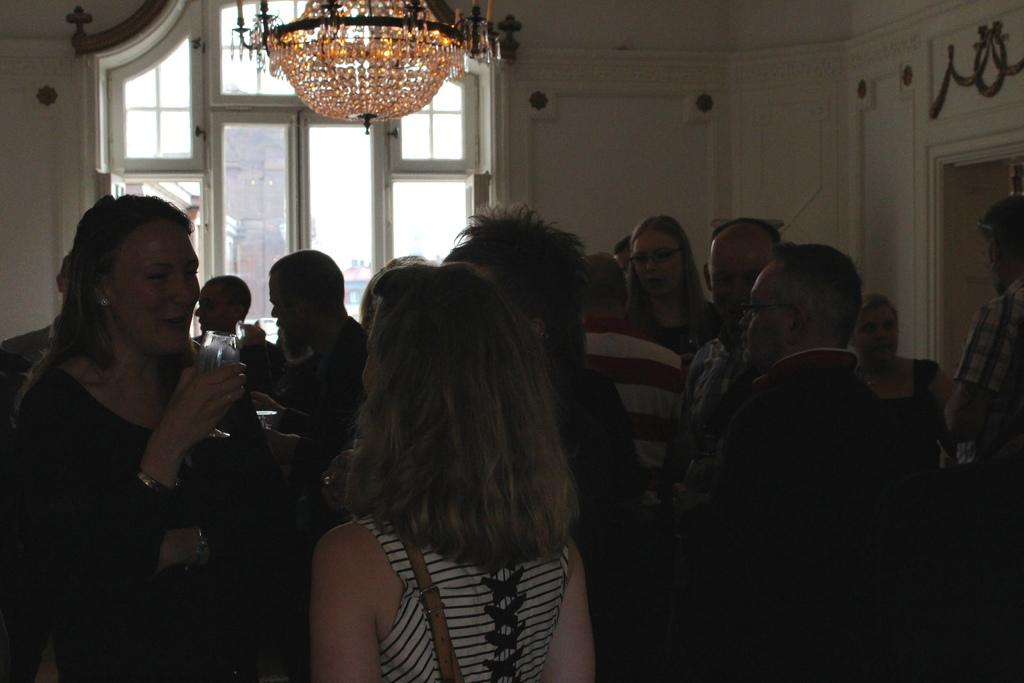How many people are in the image? There are people in the image, but the exact number is not specified. What can be seen in the background of the image? There is a wall, a glass window, and a chandelier in the background of the image. What is visible through the glass window? The sky is visible through the glass window. What type of attention is the moon receiving in the image? There is no moon present in the image, so it is not possible to determine what type of attention it might be receiving. 